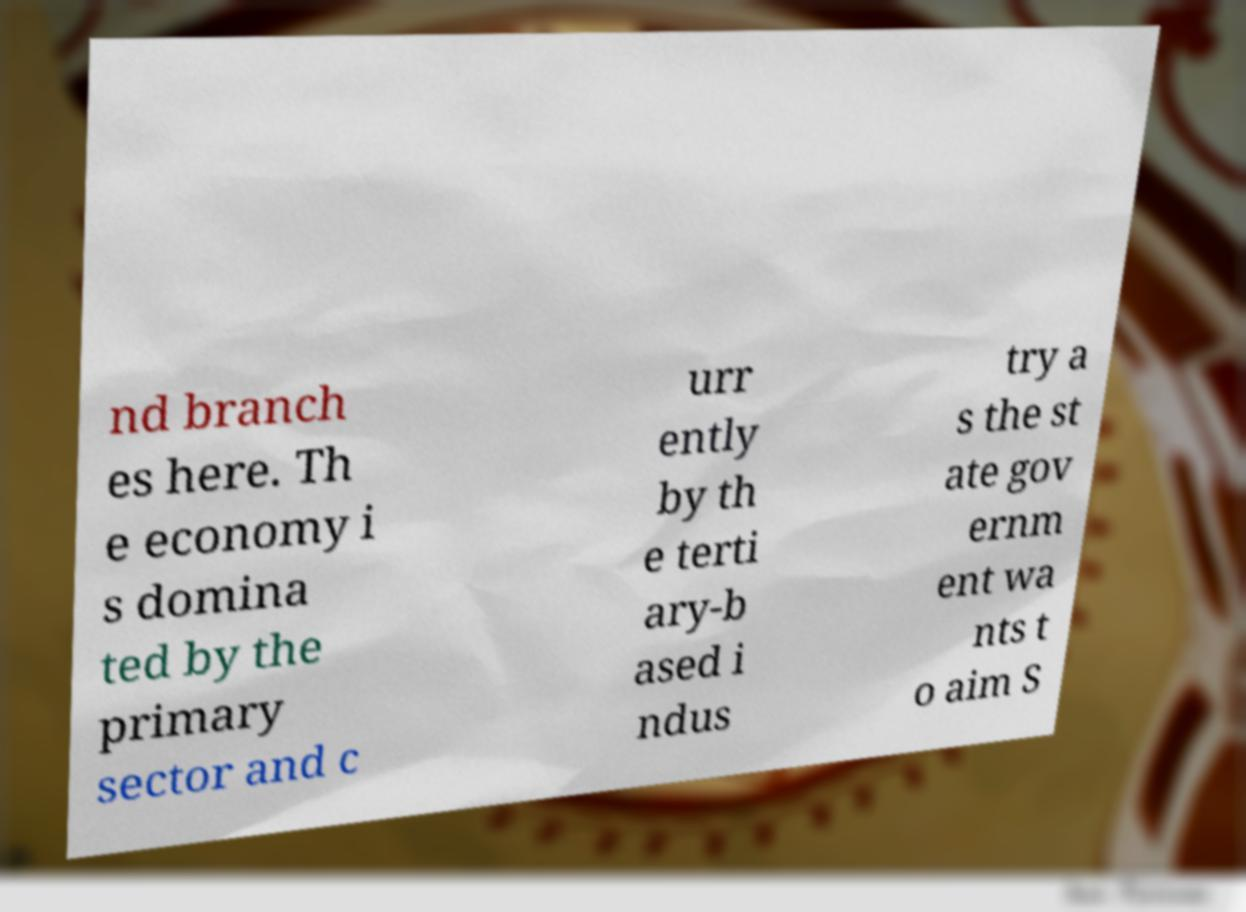For documentation purposes, I need the text within this image transcribed. Could you provide that? nd branch es here. Th e economy i s domina ted by the primary sector and c urr ently by th e terti ary-b ased i ndus try a s the st ate gov ernm ent wa nts t o aim S 